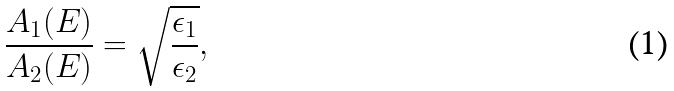<formula> <loc_0><loc_0><loc_500><loc_500>\frac { A _ { 1 } ( E ) } { A _ { 2 } ( E ) } = \sqrt { \frac { \epsilon _ { 1 } } { \epsilon _ { 2 } } } ,</formula> 